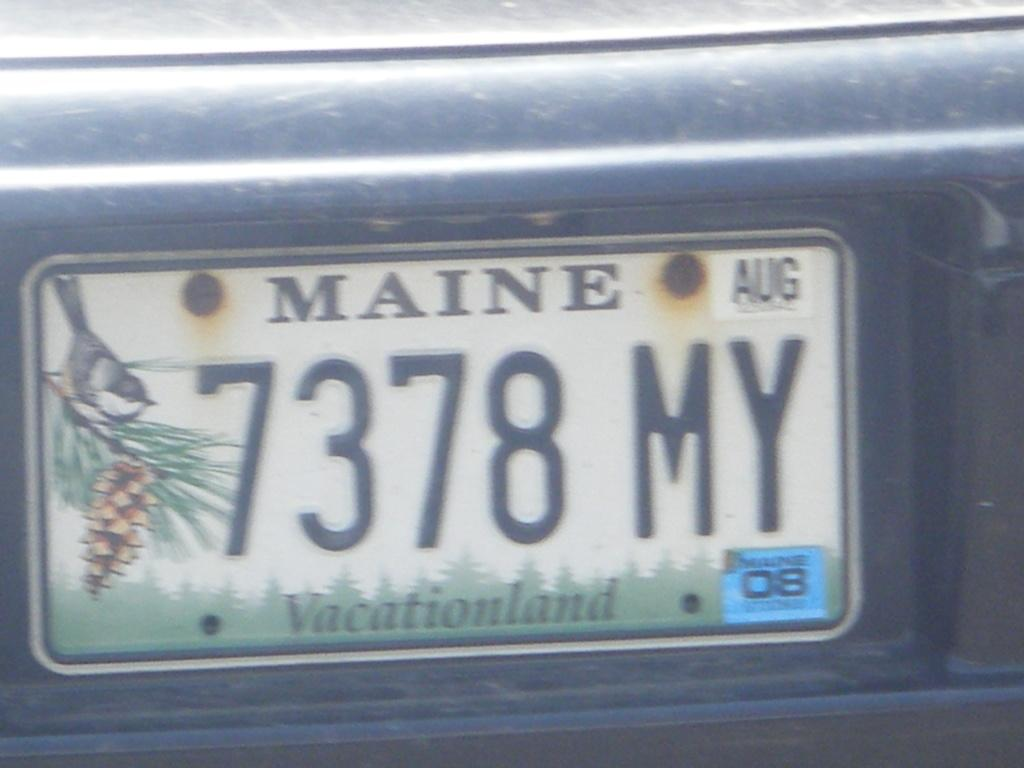<image>
Present a compact description of the photo's key features. A Maine state license plate with the word vacationland on the bottom of it. 